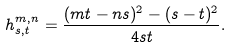<formula> <loc_0><loc_0><loc_500><loc_500>h _ { s , t } ^ { m , n } = \frac { ( m t - n s ) ^ { 2 } - ( s - t ) ^ { 2 } } { 4 s t } .</formula> 